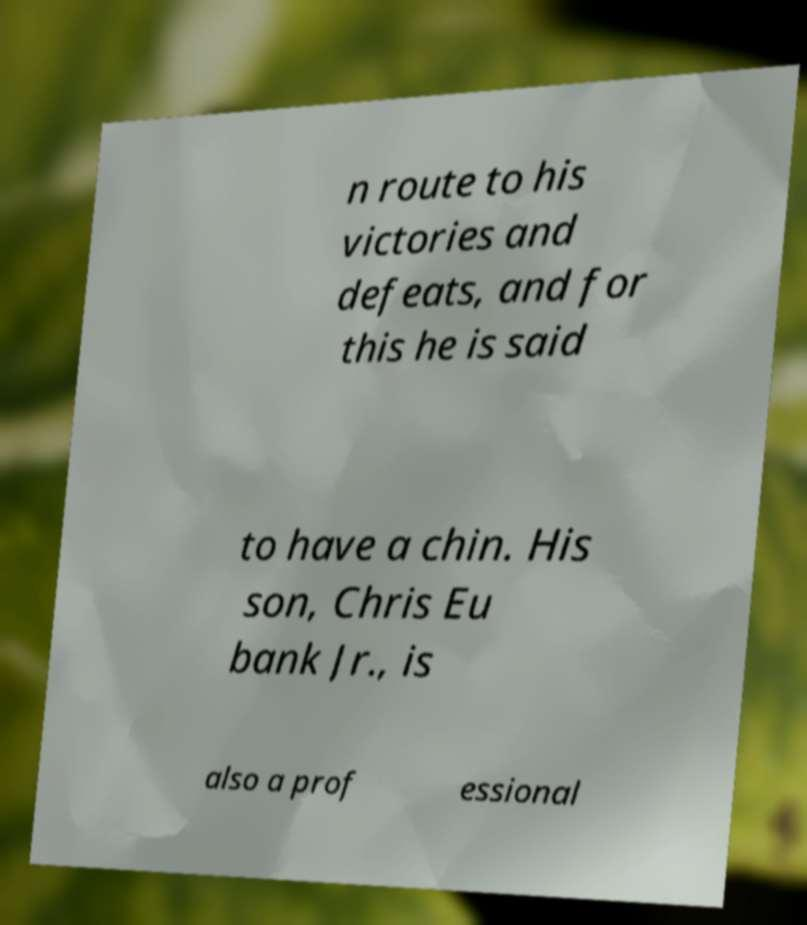There's text embedded in this image that I need extracted. Can you transcribe it verbatim? n route to his victories and defeats, and for this he is said to have a chin. His son, Chris Eu bank Jr., is also a prof essional 